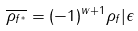Convert formula to latex. <formula><loc_0><loc_0><loc_500><loc_500>\overline { \rho _ { f ^ { * } } } = ( - 1 ) ^ { w + 1 } \rho _ { f } | \epsilon</formula> 